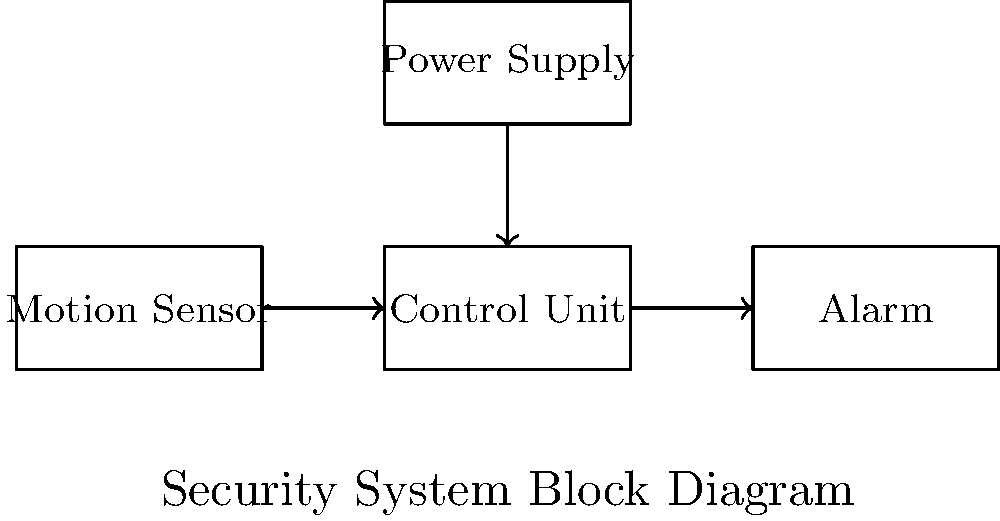As a small grocer looking to secure your local produce store, you want to design a basic alarm system for after-hours security. Based on the block diagram provided, which component would you need to adjust to increase the sensitivity of the system to detect smaller movements, potentially caused by rodents attracted to your fresh produce? To answer this question, let's analyze the components of the basic alarm system shown in the block diagram:

1. Motion Sensor: This is the input device that detects movement in the monitored area.
2. Control Unit: This processes the signals from the motion sensor and decides when to trigger the alarm.
3. Alarm: This is the output device that produces an audible or visual alert when triggered.
4. Power Supply: This provides electrical power to all components of the system.

To increase the sensitivity of the system to detect smaller movements, such as those caused by rodents, we need to focus on the component that is responsible for detecting motion. In this case, it's the Motion Sensor.

The Motion Sensor is the first component in the signal chain and is responsible for detecting any changes in the environment. By adjusting the sensitivity of the Motion Sensor, you can make it more responsive to subtle movements.

Increasing the sensitivity of the Motion Sensor would allow it to detect smaller disturbances in the monitored area, which would then be processed by the Control Unit. The Control Unit would then determine if the detected motion is significant enough to trigger the Alarm based on its programmed parameters.

It's important to note that while increasing the sensitivity of the Motion Sensor can help detect smaller movements, it may also lead to more false alarms. Therefore, you might need to balance the sensitivity with the Control Unit's programming to achieve optimal performance for your specific needs as a small grocer protecting local produce.
Answer: Motion Sensor 